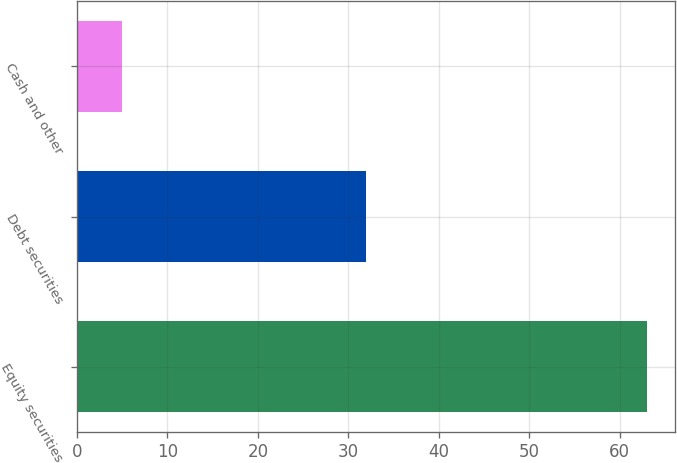Convert chart to OTSL. <chart><loc_0><loc_0><loc_500><loc_500><bar_chart><fcel>Equity securities<fcel>Debt securities<fcel>Cash and other<nl><fcel>63<fcel>32<fcel>5<nl></chart> 